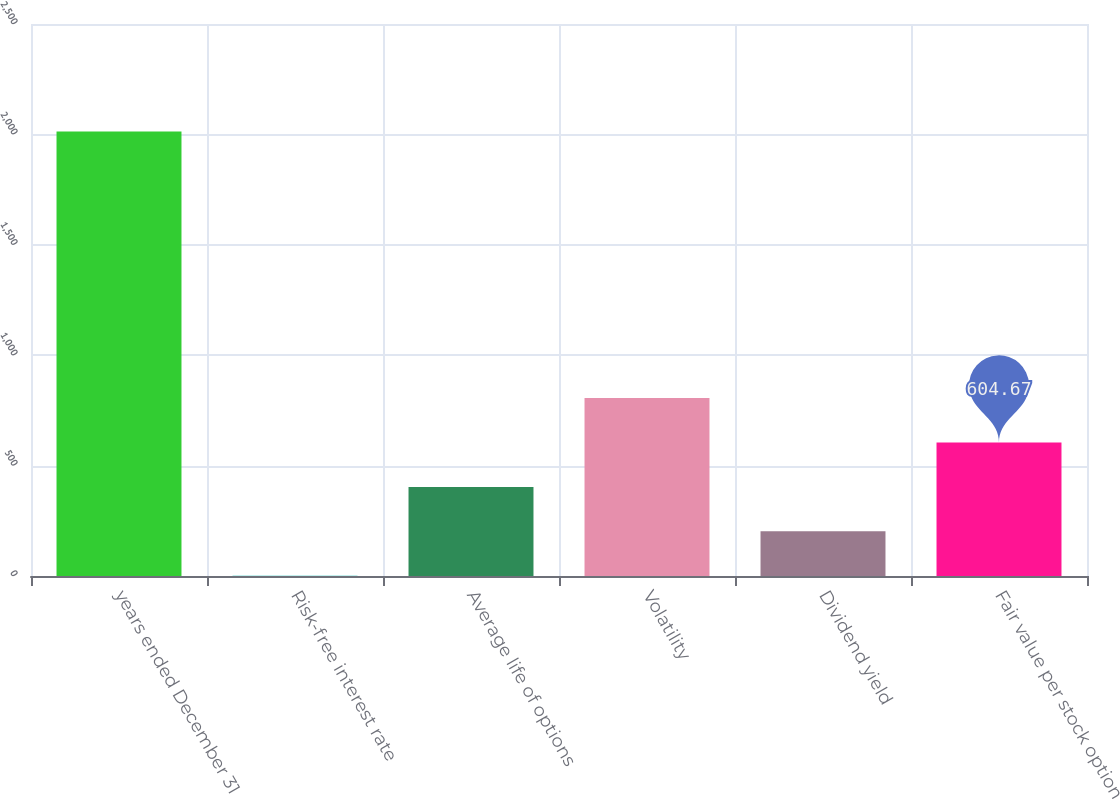<chart> <loc_0><loc_0><loc_500><loc_500><bar_chart><fcel>years ended December 31<fcel>Risk-free interest rate<fcel>Average life of options<fcel>Volatility<fcel>Dividend yield<fcel>Fair value per stock option<nl><fcel>2013<fcel>1.1<fcel>403.48<fcel>805.86<fcel>202.29<fcel>604.67<nl></chart> 